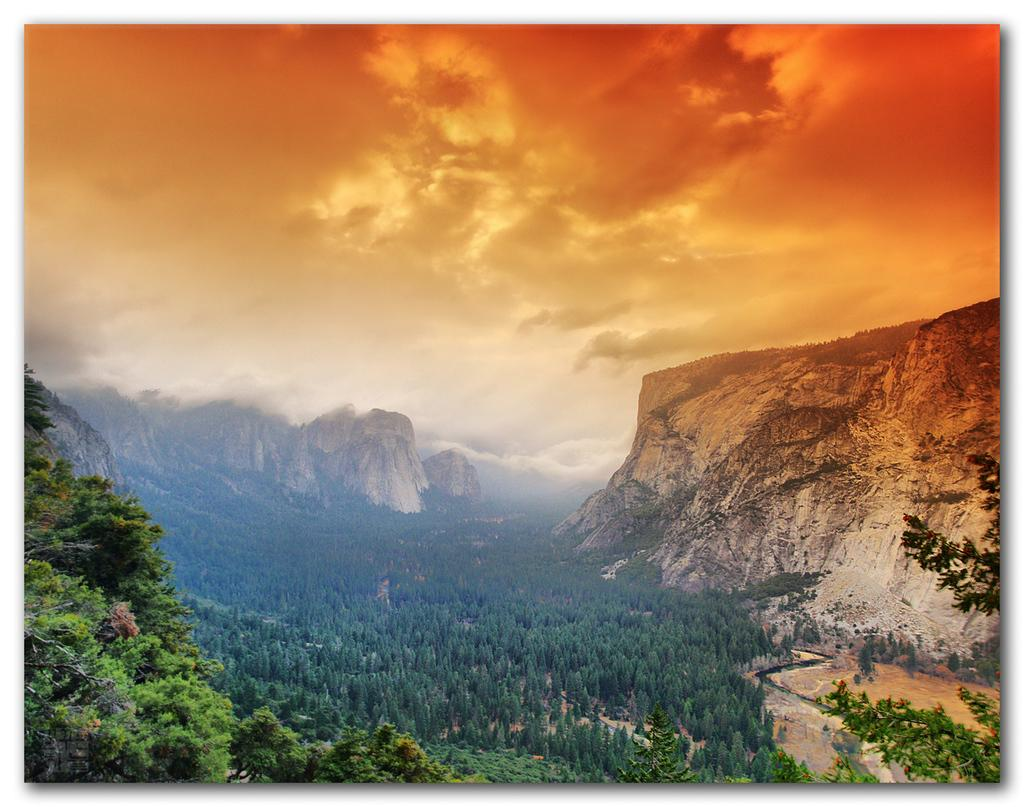What type of natural environment is depicted in the image? The image features many trees in the area. What geographical features can be seen in the image? There are mountains and hills in the image. What is visible at the top of the image? The sky is clear and visible at the top of the image. Can you tell me how many ladybugs are crawling on the spoon in the image? There is no spoon or ladybugs present in the image. What type of station is visible in the image? There is no station present in the image. 